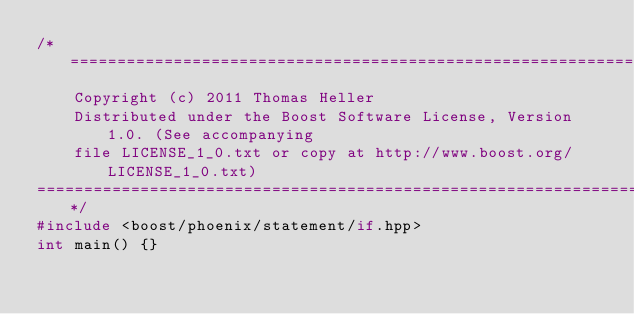<code> <loc_0><loc_0><loc_500><loc_500><_C++_>/*=============================================================================
    Copyright (c) 2011 Thomas Heller
    Distributed under the Boost Software License, Version 1.0. (See accompanying
    file LICENSE_1_0.txt or copy at http://www.boost.org/LICENSE_1_0.txt)
==============================================================================*/
#include <boost/phoenix/statement/if.hpp>
int main() {}
</code> 